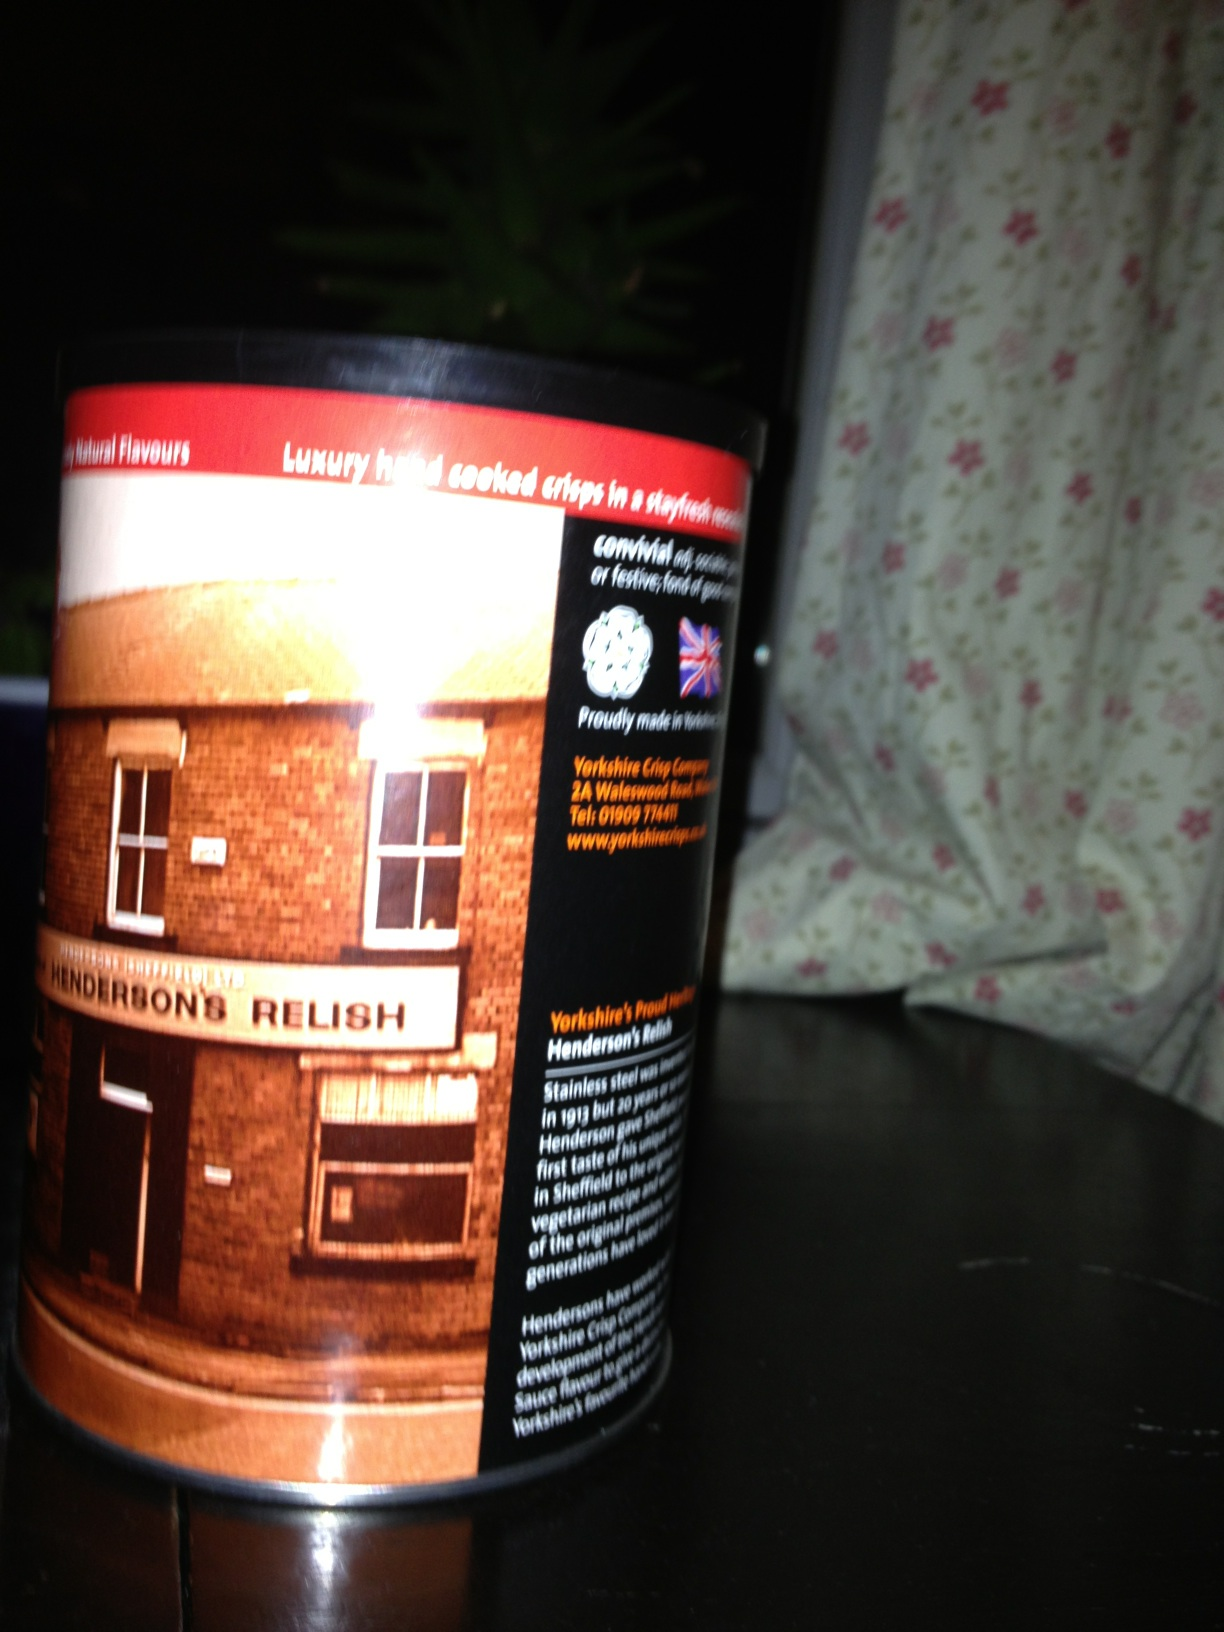What is the significance of the scene depicted on the can? The scene depicted on the can showcases the iconic building associated with Henderson's Relish. This historic site in Sheffield, England, represents the long-standing heritage and tradition of the brand, which has been crafting its unique relish for generations. The image highlights the pride and cultural significance that the local community holds for this beloved condiment. 